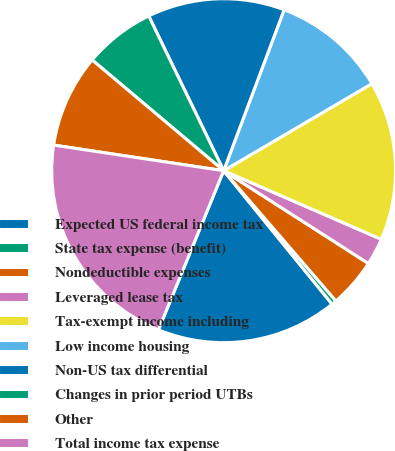<chart> <loc_0><loc_0><loc_500><loc_500><pie_chart><fcel>Expected US federal income tax<fcel>State tax expense (benefit)<fcel>Nondeductible expenses<fcel>Leveraged lease tax<fcel>Tax-exempt income including<fcel>Low income housing<fcel>Non-US tax differential<fcel>Changes in prior period UTBs<fcel>Other<fcel>Total income tax expense<nl><fcel>17.05%<fcel>0.46%<fcel>4.61%<fcel>2.54%<fcel>14.98%<fcel>10.83%<fcel>12.9%<fcel>6.68%<fcel>8.76%<fcel>21.19%<nl></chart> 